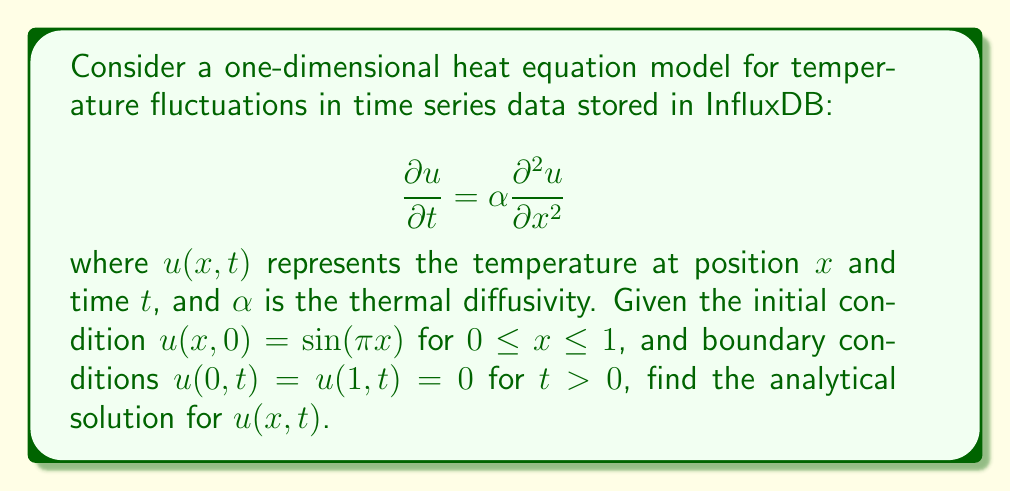Can you solve this math problem? To solve this problem, we'll use the method of separation of variables:

1) Assume the solution has the form: $u(x,t) = X(x)T(t)$

2) Substitute this into the heat equation:
   $$X(x)T'(t) = \alpha X''(x)T(t)$$
   $$\frac{T'(t)}{T(t)} = \alpha \frac{X''(x)}{X(x)} = -\lambda$$
   where $\lambda$ is a constant.

3) This gives us two ODEs:
   $$T'(t) + \alpha \lambda T(t) = 0$$
   $$X''(x) + \lambda X(x) = 0$$

4) The boundary conditions imply $X(0) = X(1) = 0$, which leads to the eigenvalue problem:
   $$\lambda_n = n^2\pi^2, \quad X_n(x) = \sin(n\pi x), \quad n = 1,2,3,...$$

5) The general solution is:
   $$u(x,t) = \sum_{n=1}^{\infty} c_n \sin(n\pi x)e^{-\alpha n^2\pi^2 t}$$

6) To find $c_n$, we use the initial condition:
   $$u(x,0) = \sin(\pi x) = \sum_{n=1}^{\infty} c_n \sin(n\pi x)$$

7) This implies $c_1 = 1$ and $c_n = 0$ for $n > 1$.

Therefore, the analytical solution is:
$$u(x,t) = \sin(\pi x)e^{-\alpha \pi^2 t}$$
Answer: $u(x,t) = \sin(\pi x)e^{-\alpha \pi^2 t}$ 